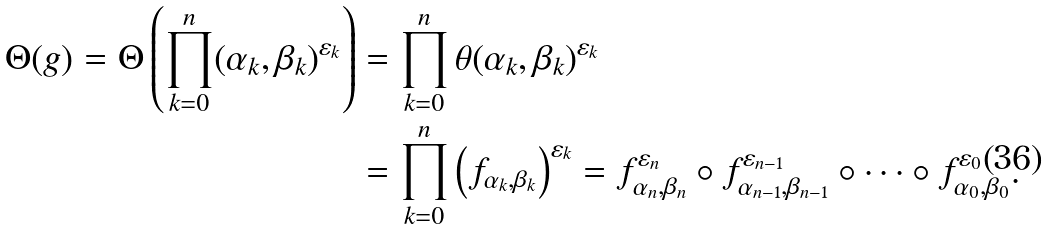Convert formula to latex. <formula><loc_0><loc_0><loc_500><loc_500>\Theta ( g ) = \Theta \left ( \prod _ { k = 0 } ^ { n } ( \alpha _ { k } , \beta _ { k } ) ^ { \varepsilon _ { k } } \right ) & = \prod _ { k = 0 } ^ { n } \theta ( \alpha _ { k } , \beta _ { k } ) ^ { \varepsilon _ { k } } \\ & = \prod _ { k = 0 } ^ { n } \left ( f _ { \alpha _ { k } , \beta _ { k } } \right ) ^ { \varepsilon _ { k } } = f _ { \alpha _ { n } , \beta _ { n } } ^ { \varepsilon _ { n } } \circ f _ { \alpha _ { n - 1 } , \beta _ { n - 1 } } ^ { \varepsilon _ { n - 1 } } \circ \dots \circ f _ { \alpha _ { 0 } , \beta _ { 0 } } ^ { \varepsilon _ { 0 } } .</formula> 